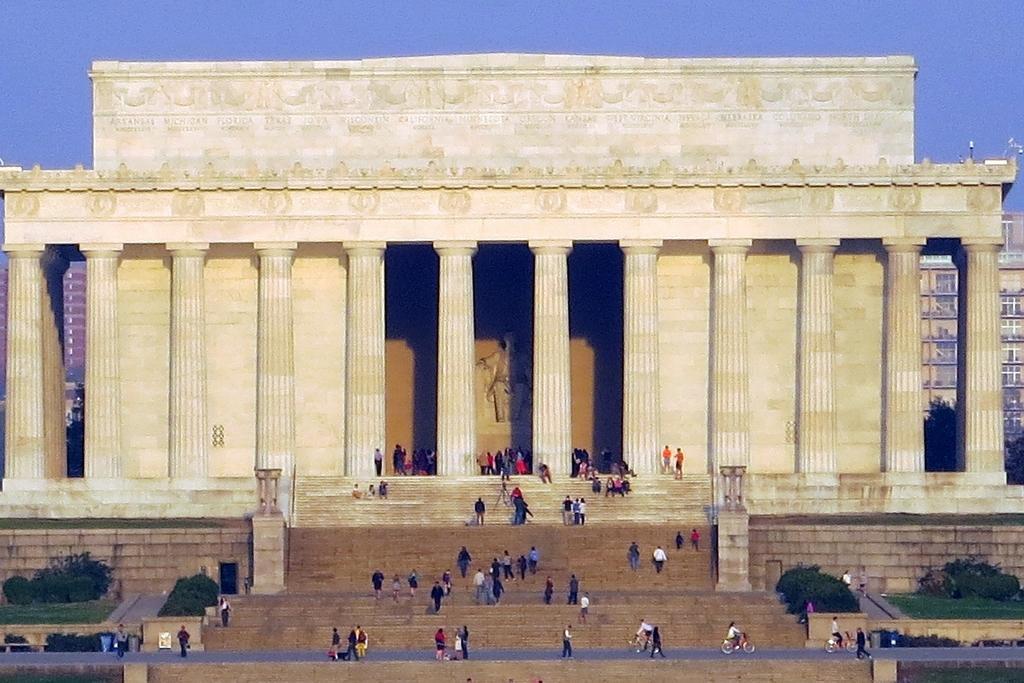Describe this image in one or two sentences. In this picture I can see the bushes on either side of this image, in the middle there are few people and it looks like a monument, in the background there are buildings, at the top I can see the sky. 